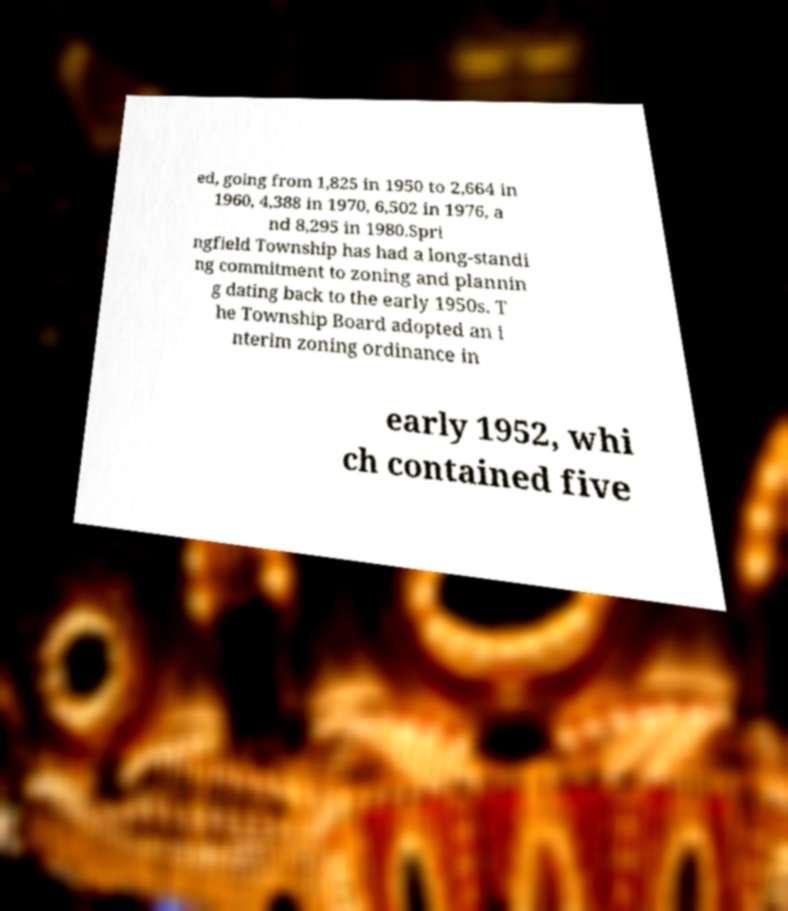Can you read and provide the text displayed in the image?This photo seems to have some interesting text. Can you extract and type it out for me? ed, going from 1,825 in 1950 to 2,664 in 1960, 4,388 in 1970, 6,502 in 1976, a nd 8,295 in 1980.Spri ngfield Township has had a long-standi ng commitment to zoning and plannin g dating back to the early 1950s. T he Township Board adopted an i nterim zoning ordinance in early 1952, whi ch contained five 